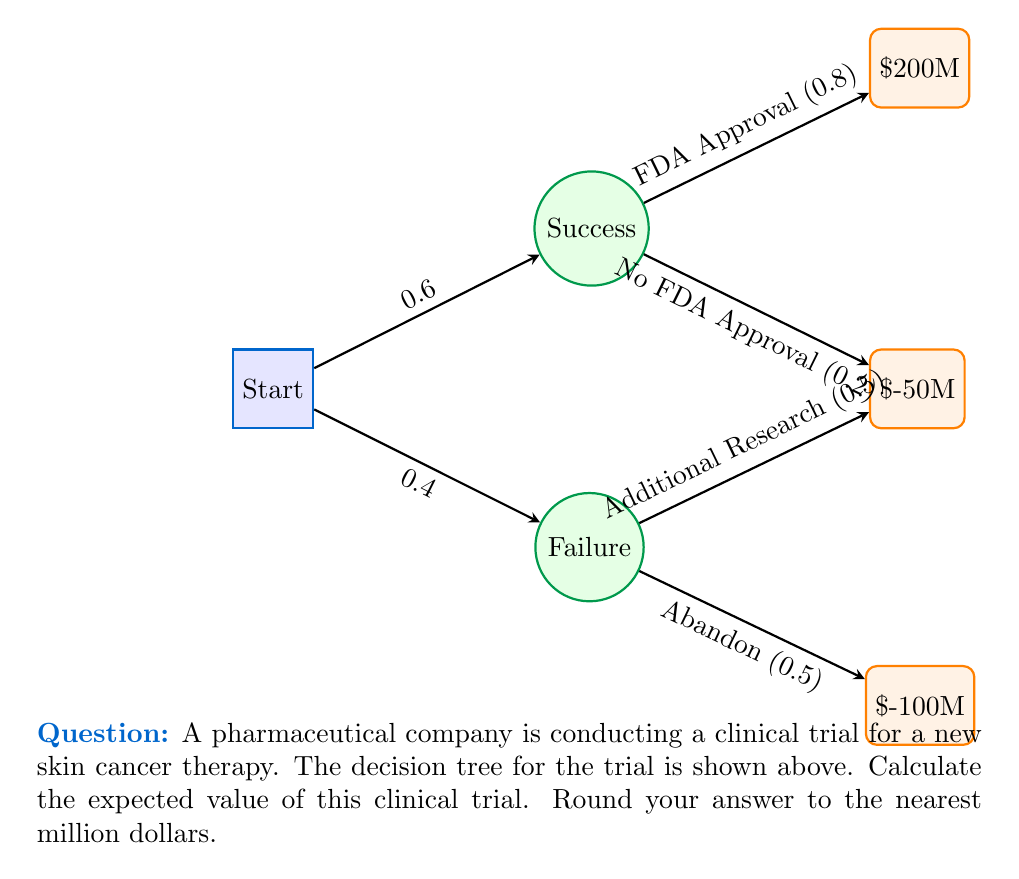Could you help me with this problem? To calculate the expected value, we'll use the decision tree and work backwards:

1) First, let's calculate the expected value of the "Failure" branch:
   $$EV(\text{Failure}) = 0.5 \times (-50M) + 0.5 \times (-100M) = -75M$$

2) Now, we can calculate the expected value of the entire tree:

   $$\begin{align}
   EV(\text{Trial}) &= P(\text{Success}) \times [P(\text{FDA Approval}) \times 200M + P(\text{No FDA Approval}) \times (-50M)] \\
   &+ P(\text{Failure}) \times EV(\text{Failure})
   \end{align}$$

3) Plugging in the values:

   $$\begin{align}
   EV(\text{Trial}) &= 0.6 \times [0.8 \times 200M + 0.2 \times (-50M)] + 0.4 \times (-75M) \\
   &= 0.6 \times (160M - 10M) + 0.4 \times (-75M) \\
   &= 0.6 \times 150M - 30M \\
   &= 90M - 30M \\
   &= 60M
   \end{align}$$

4) Rounding to the nearest million dollars:

   The expected value is $60 million.
Answer: $60 million 